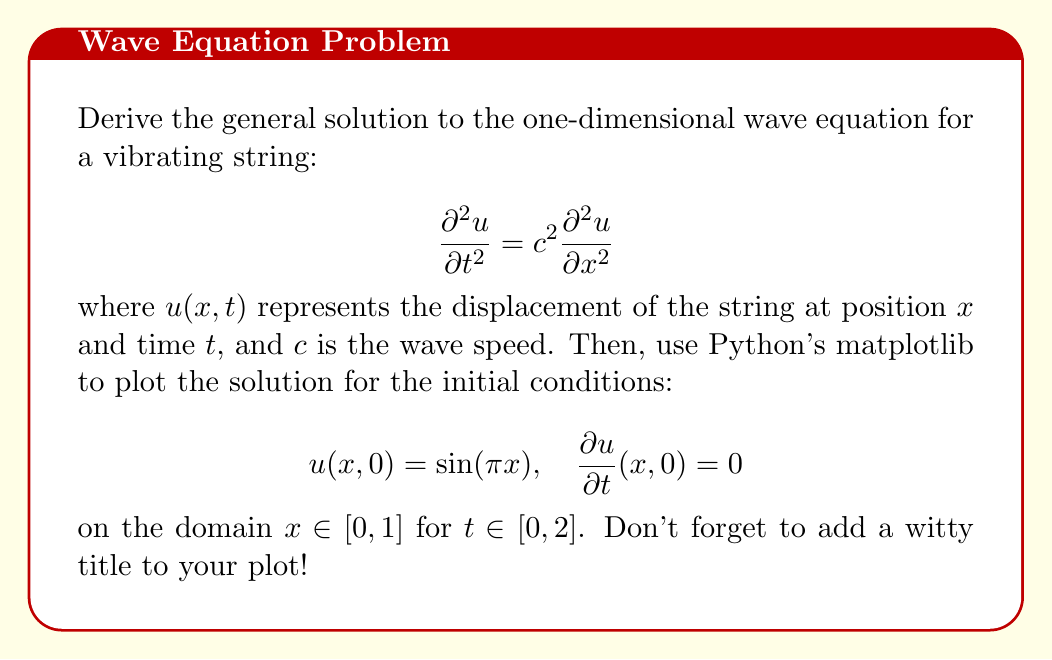Show me your answer to this math problem. Let's approach this step-by-step:

1) The general solution to the wave equation is given by d'Alembert's formula:

   $$u(x,t) = f(x-ct) + g(x+ct)$$

   where $f$ and $g$ are arbitrary functions.

2) Given the initial conditions, we need to determine $f$ and $g$. At $t=0$:

   $$u(x,0) = f(x) + g(x) = \sin(\pi x)$$
   $$\frac{\partial u}{\partial t}(x,0) = -cf'(x) + cg'(x) = 0$$

3) From the second equation, we can deduce that $f'(x) = g'(x)$, which means $f(x) = g(x) + constant$.

4) Substituting this into the first equation:

   $$2f(x) + constant = \sin(\pi x)$$

   $$f(x) = \frac{1}{2}\sin(\pi x) - \frac{constant}{2}$$
   $$g(x) = \frac{1}{2}\sin(\pi x) + \frac{constant}{2}$$

5) The constant cancels out in the general solution, so we can ignore it. Thus, our solution is:

   $$u(x,t) = \frac{1}{2}\sin(\pi(x-ct)) + \frac{1}{2}\sin(\pi(x+ct))$$

6) To plot this using matplotlib, we can use the following Python code:

```python
import numpy as np
import matplotlib.pyplot as plt
from mpl_toolkits.mplot3d import Axes3D

def u(x, t, c):
    return 0.5 * (np.sin(np.pi*(x-c*t)) + np.sin(np.pi*(x+c*t)))

x = np.linspace(0, 1, 100)
t = np.linspace(0, 2, 100)
X, T = np.meshgrid(x, t)

c = 1  # wave speed
Z = u(X, T, c)

fig = plt.figure(figsize=(10, 8))
ax = fig.add_subplot(111, projection='3d')
surf = ax.plot_surface(X, T, Z, cmap='viridis')
ax.set_xlabel('x')
ax.set_ylabel('t')
ax.set_zlabel('u(x,t)')
ax.set_title("Wave Equation: Riding the Sine Wave of Math!")
plt.colorbar(surf)
plt.show()
```

This code will generate a 3D surface plot of the solution.
Answer: The general solution to the wave equation is:

$$u(x,t) = \frac{1}{2}\sin(\pi(x-ct)) + \frac{1}{2}\sin(\pi(x+ct))$$

The Python code provided in the explanation will generate a 3D plot of this solution for the given initial conditions. 